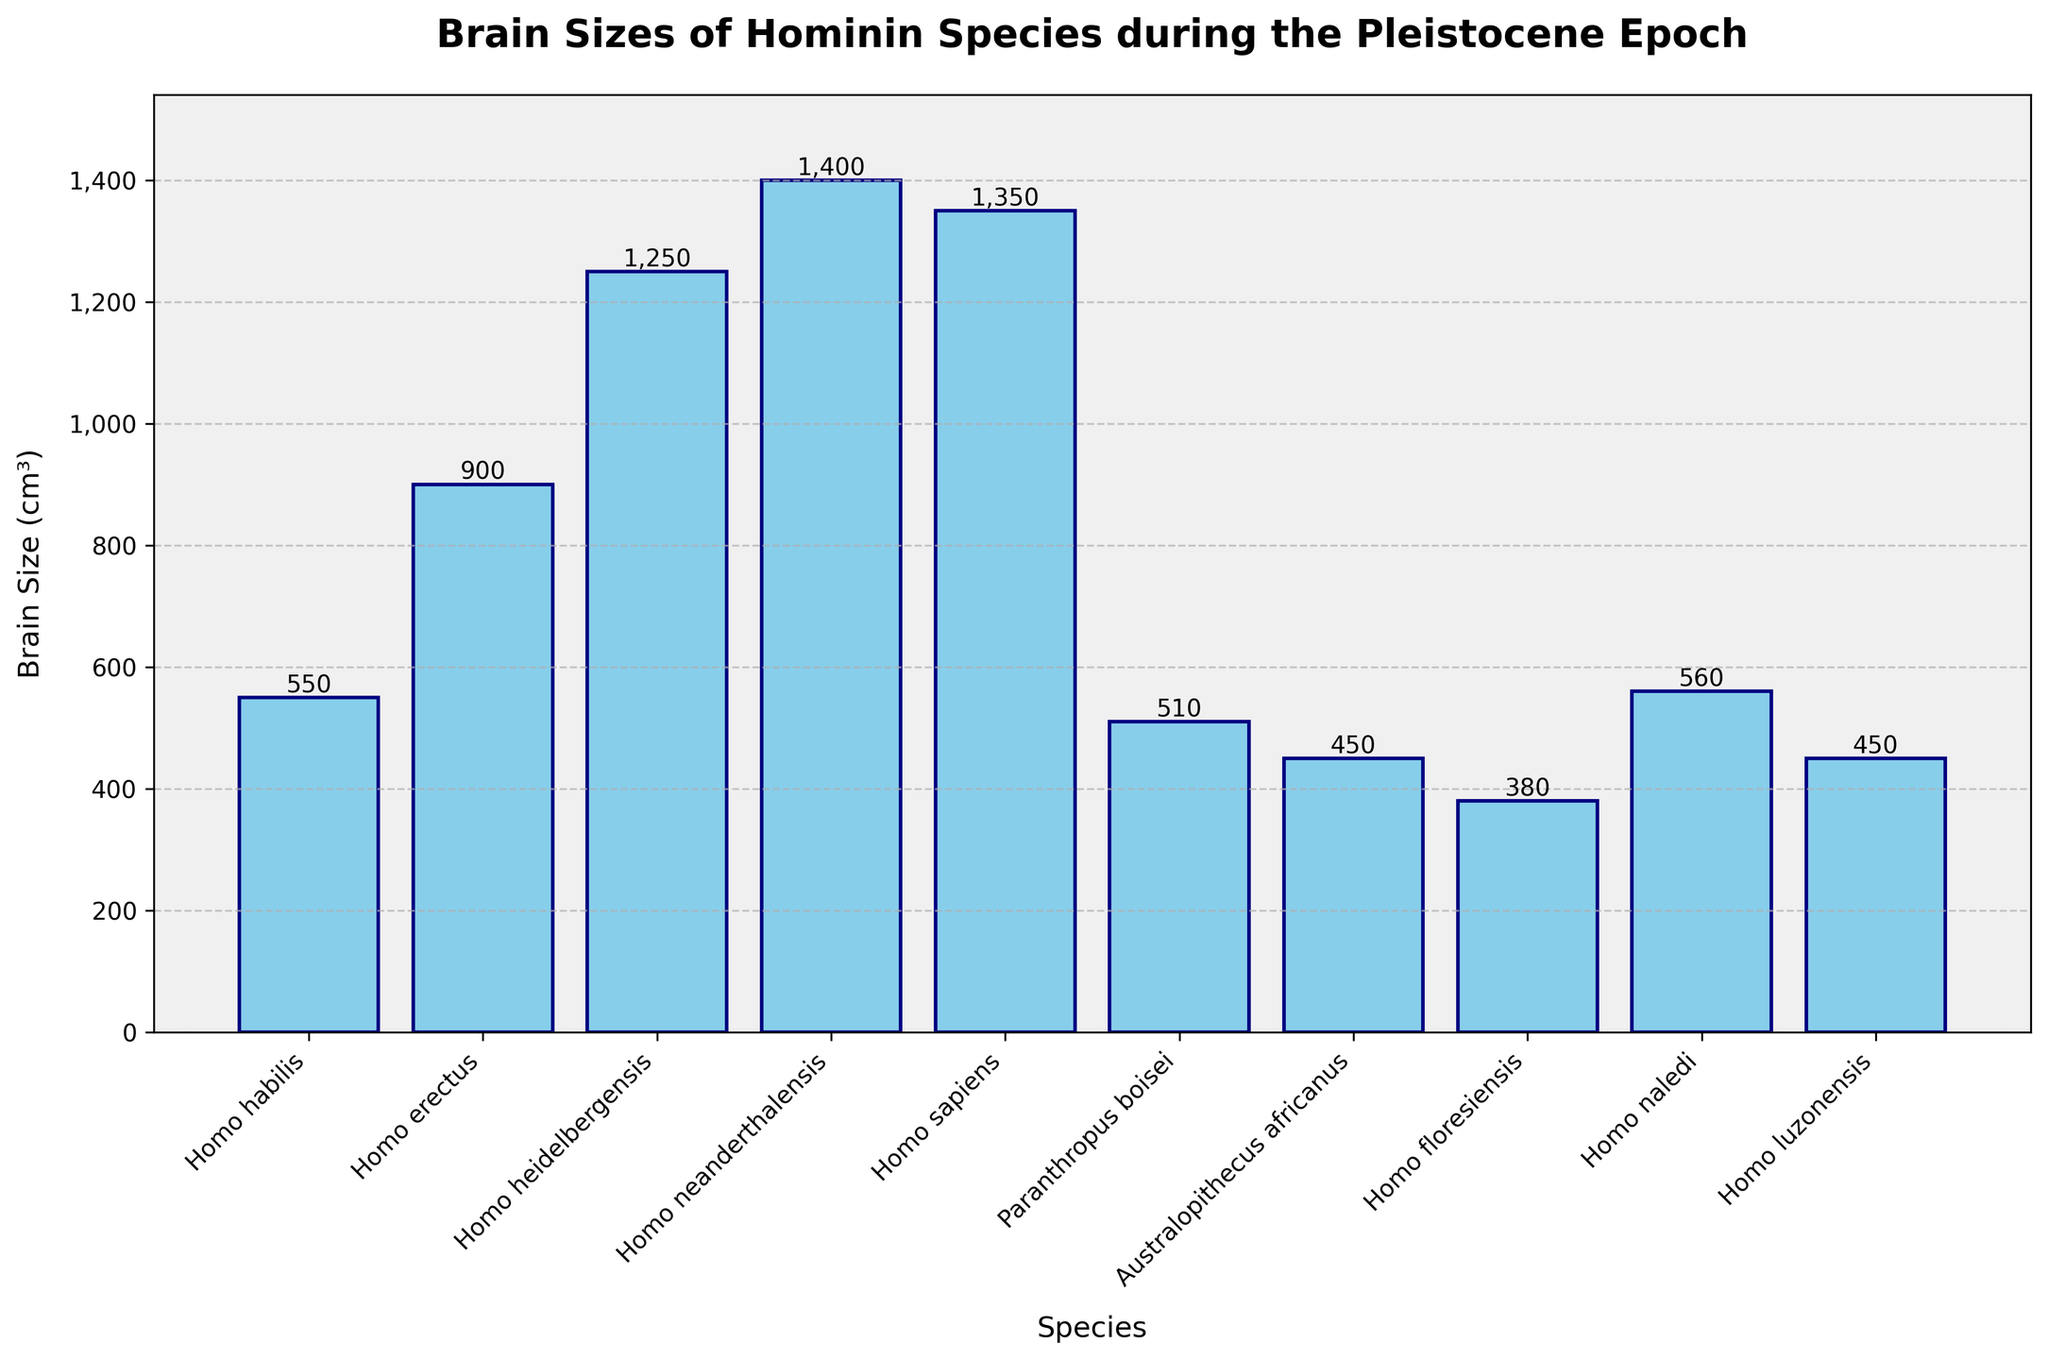What's the brain size of Homo neanderthalensis? To find this, locate the bar corresponding to Homo neanderthalensis and read the value at the top of the bar. The height indicates the brain size.
Answer: 1400 cm³ Which hominin species has the smallest brain size? Look at all the bars and identify the one with the smallest height. Homo floresiensis has the shortest bar, indicating it has the smallest brain size.
Answer: Homo floresiensis What is the difference in brain size between Homo sapiens and Homo erectus? Identify the heights of the bars for Homo sapiens (1350 cm³) and Homo erectus (900 cm³). Subtract the smaller value from the larger one: 1350 - 900.
Answer: 450 cm³ What's the average brain size of the three species with the smallest brains? The three species with the smallest brains are Homo floresiensis (380 cm³), Australopithecus africanus (450 cm³), and Homo luzonensis (450 cm³). The average is calculated by summing these values and dividing by 3: (380 + 450 + 450) / 3.
Answer: 427 cm³ Which species has a larger brain size, Homo heidelbergensis or Homo erectus? Compare the heights of the bars for Homo heidelbergensis (1250 cm³) and Homo erectus (900 cm³). Homo heidelbergensis has a taller bar, indicating a larger brain size.
Answer: Homo heidelbergensis How many species have a brain size greater than 1000 cm³? Identify the bars with heights above 1000 cm³. These are Homo heidelbergensis, Homo neanderthalensis, and Homo sapiens. Count the number of such bars.
Answer: 3 species What is the total brain size of Homo habilis, Homo naledi, and Paranthropus boisei combined? Sum the brain sizes of these species: Homo habilis (550 cm³), Homo naledi (560 cm³), and Paranthropus boisei (510 cm³). The total is 550 + 560 + 510.
Answer: 1620 cm³ Which has a smaller brain size, Homo luzonensis or Australopithecus africanus? Compare the heights of the bars for Homo luzonensis (450 cm³) and Australopithecus africanus (450 cm³). Both have the same height, indicating equal brain sizes.
Answer: They are equal 